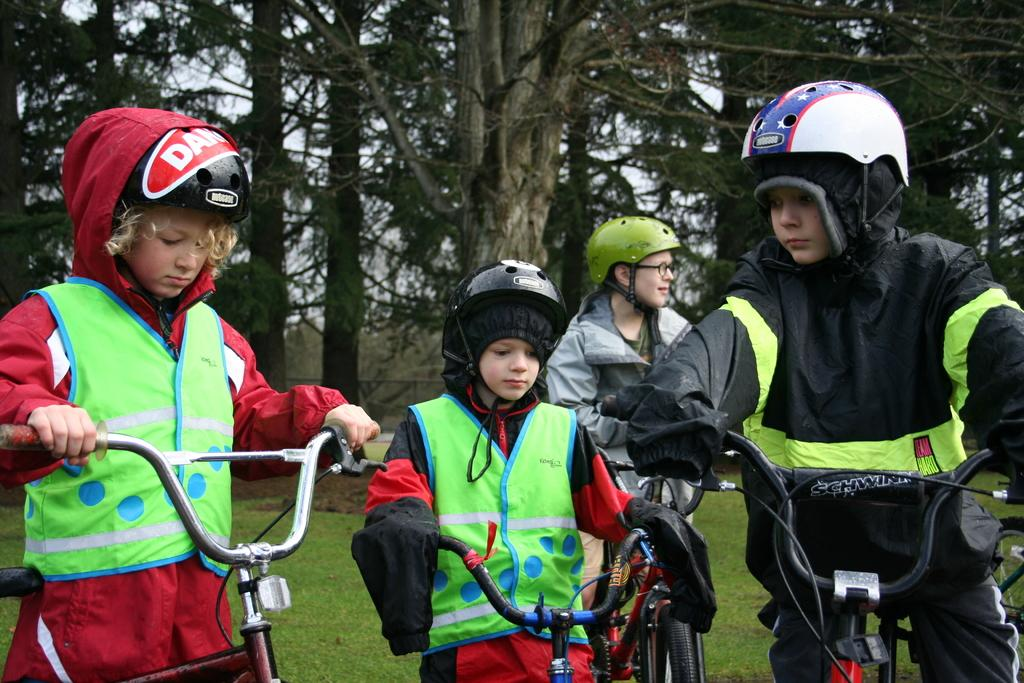What are the people in the image doing? The people in the image are riding bicycles. What safety precaution are the people taking while riding bicycles? The people are wearing helmets on their heads. What type of vegetation can be seen in the image? There is a tree visible in the image. How many legs does the bicycle have in the image? Bicycles do not have legs; they have wheels. In the image, the bicycles have two wheels each. 